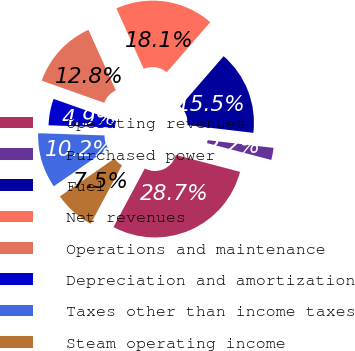Convert chart to OTSL. <chart><loc_0><loc_0><loc_500><loc_500><pie_chart><fcel>Operating revenues<fcel>Purchased power<fcel>Fuel<fcel>Net revenues<fcel>Operations and maintenance<fcel>Depreciation and amortization<fcel>Taxes other than income taxes<fcel>Steam operating income<nl><fcel>28.73%<fcel>2.23%<fcel>15.48%<fcel>18.13%<fcel>12.83%<fcel>4.88%<fcel>10.18%<fcel>7.53%<nl></chart> 